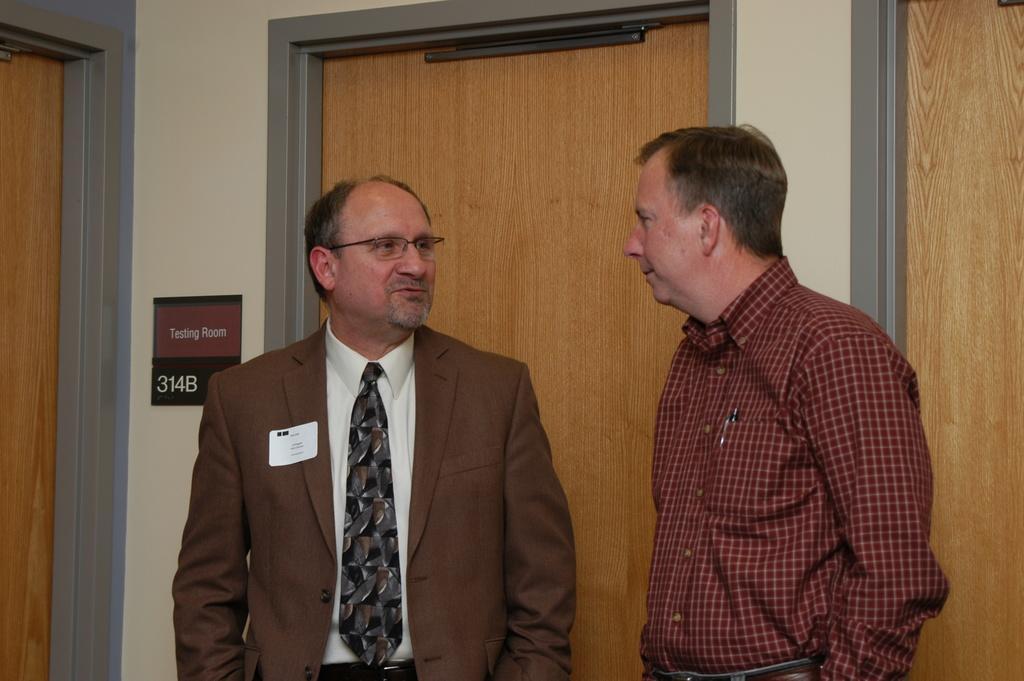Please provide a concise description of this image. In this picture I can observe two men. One of them is wearing a coat and tie. In the background I can observe doors. 